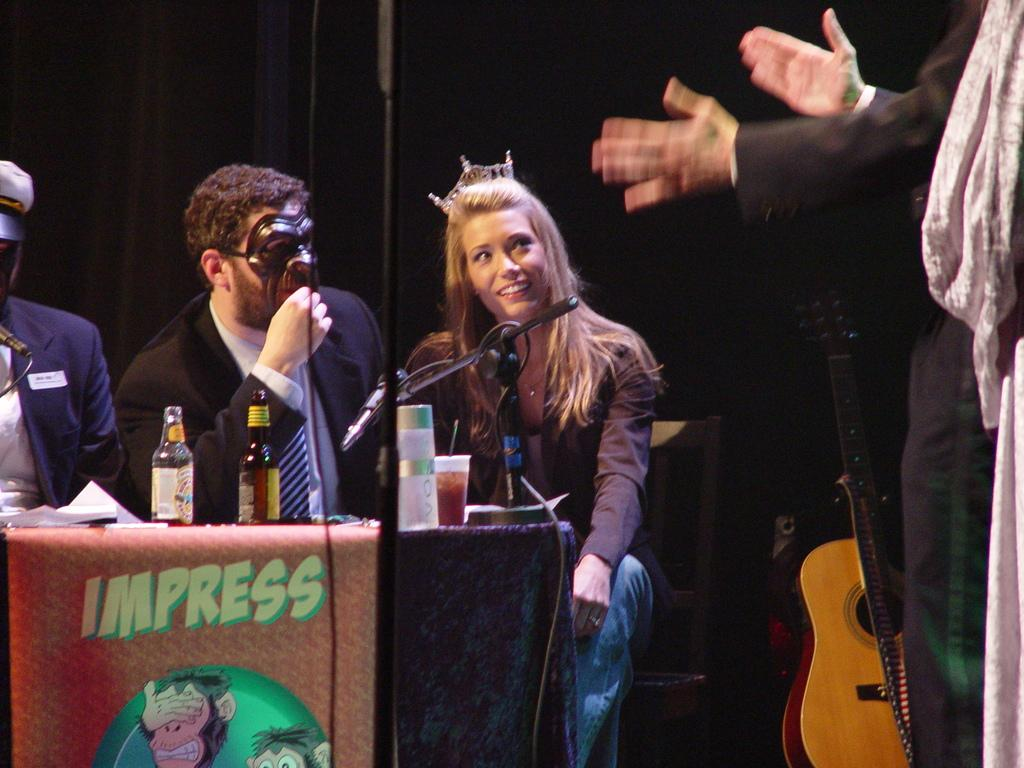How many people are in the image? There is a group of people in the image. What are the people doing in the image? The people are sitting on chairs. Where are the chairs located in relation to the table? The chairs are in front of a table. What can be found on the table? There are objects on the table. What musical instrument is present in the image? There is a guitar in the image. What type of carriage can be seen in the image? There is no carriage present in the image. Is the table in the image shaped like a square? The shape of the table is not mentioned in the provided facts, so it cannot be determined from the image. 